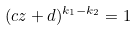<formula> <loc_0><loc_0><loc_500><loc_500>( c z + d ) ^ { k _ { 1 } - k _ { 2 } } = 1</formula> 